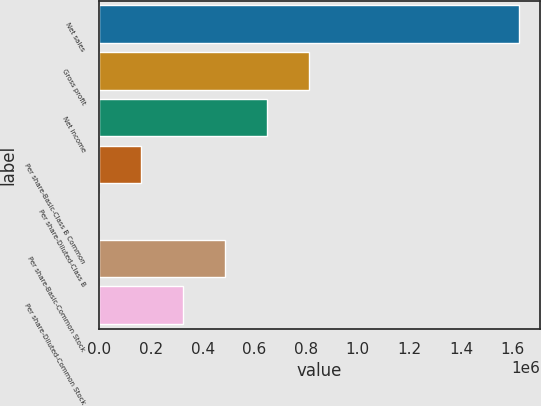Convert chart to OTSL. <chart><loc_0><loc_0><loc_500><loc_500><bar_chart><fcel>Net sales<fcel>Gross profit<fcel>Net income<fcel>Per share-Basic-Class B Common<fcel>Per share-Diluted-Class B<fcel>Per share-Basic-Common Stock<fcel>Per share-Diluted-Common Stock<nl><fcel>1.62425e+06<fcel>812125<fcel>649700<fcel>162426<fcel>0.8<fcel>487275<fcel>324850<nl></chart> 